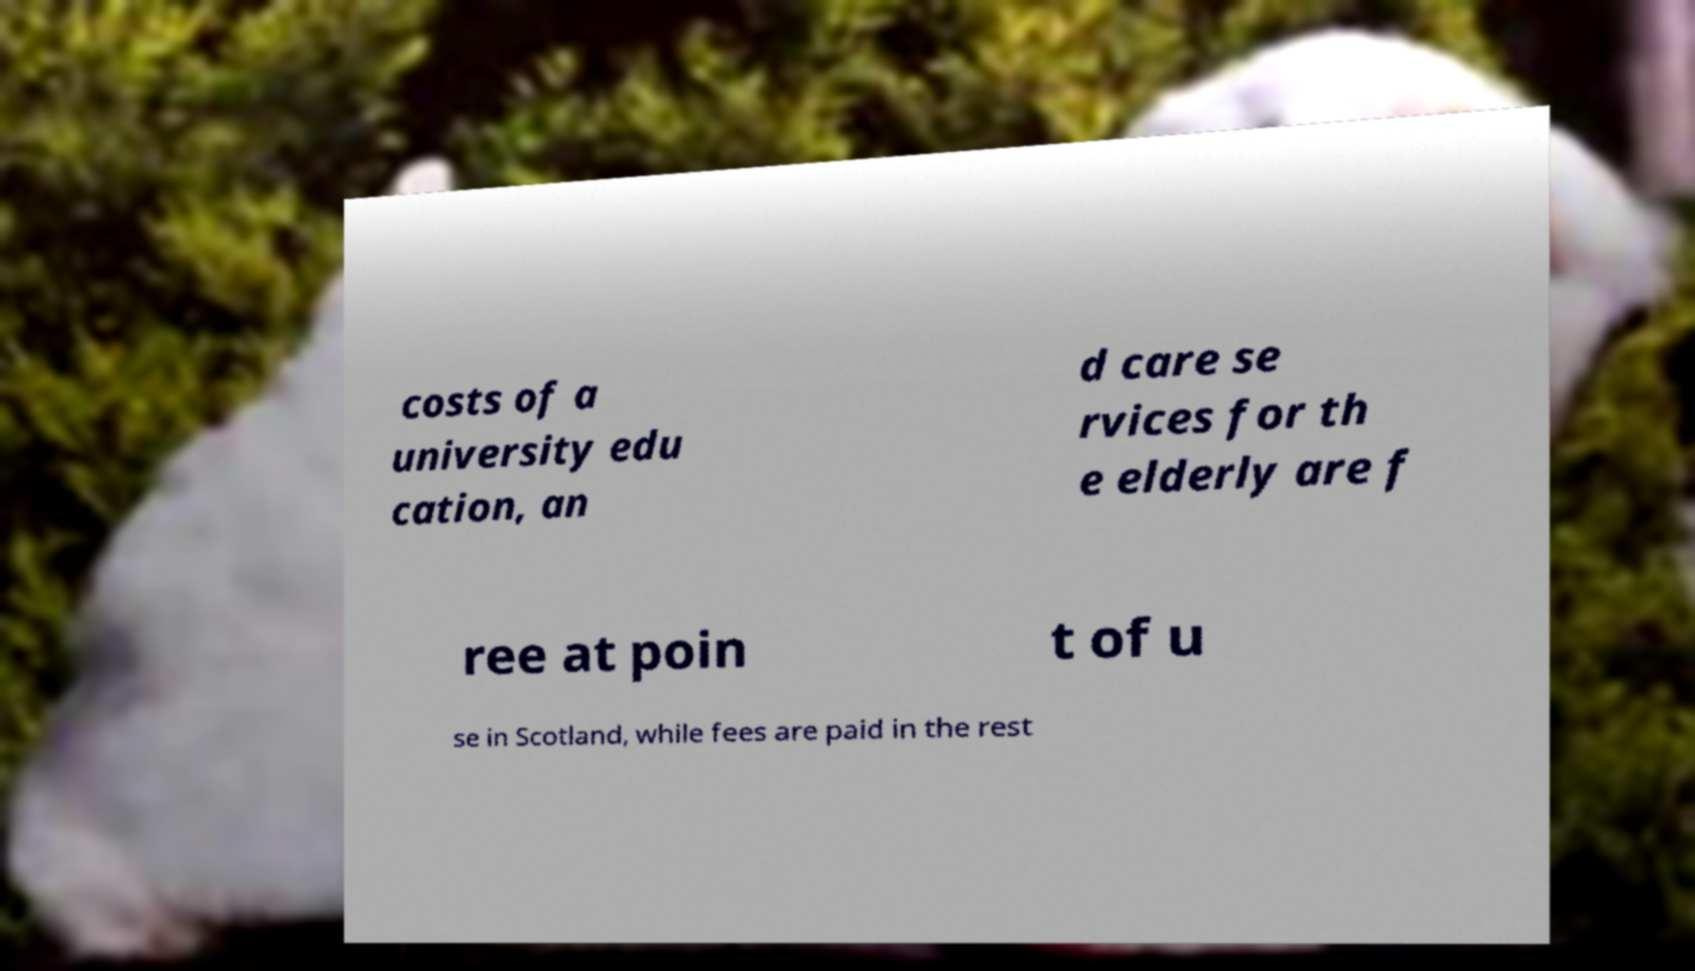Please read and relay the text visible in this image. What does it say? costs of a university edu cation, an d care se rvices for th e elderly are f ree at poin t of u se in Scotland, while fees are paid in the rest 